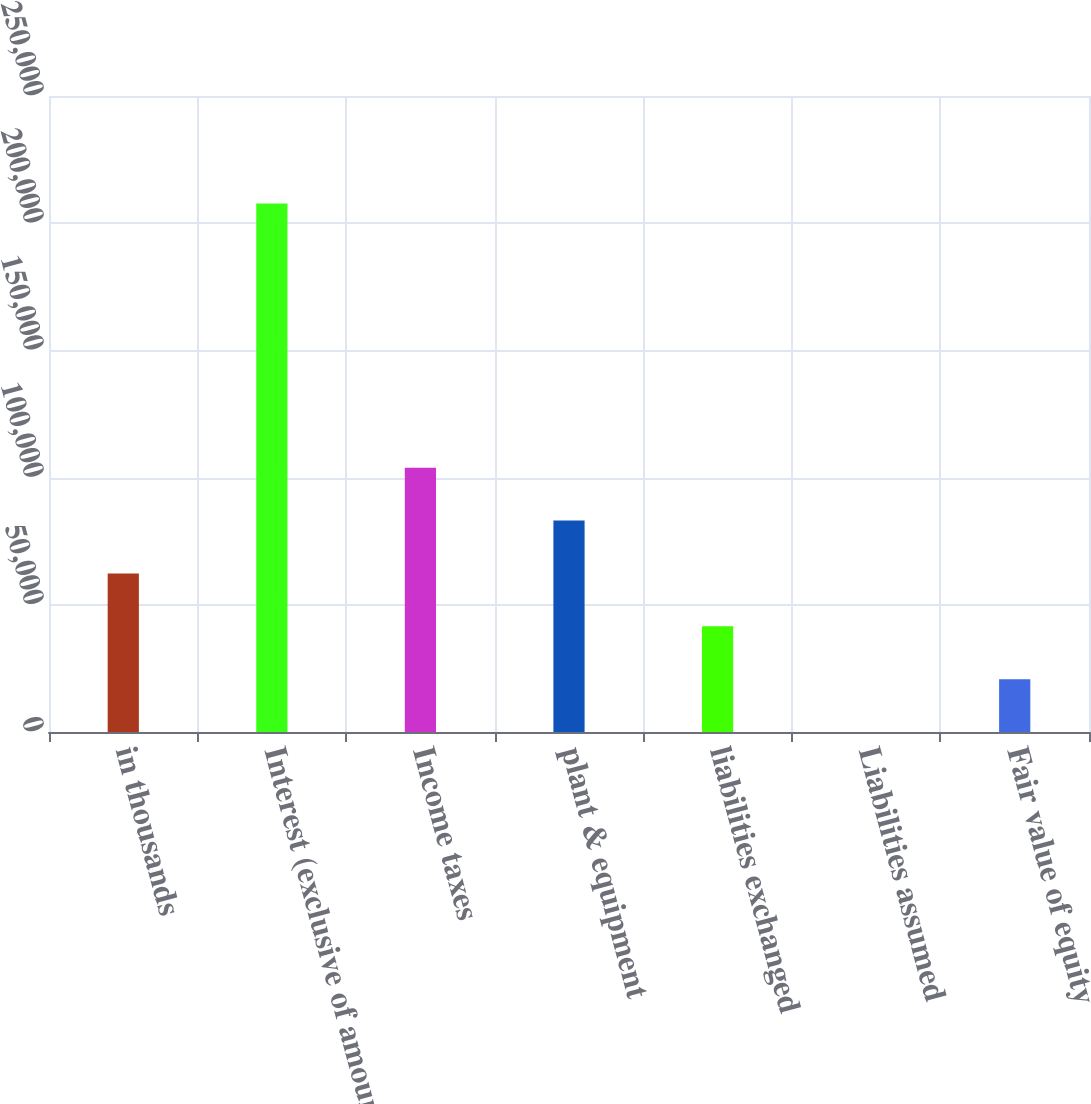<chart> <loc_0><loc_0><loc_500><loc_500><bar_chart><fcel>in thousands<fcel>Interest (exclusive of amount<fcel>Income taxes<fcel>plant & equipment<fcel>liabilities exchanged<fcel>Liabilities assumed<fcel>Fair value of equity<nl><fcel>62324.2<fcel>207745<fcel>103873<fcel>83098.6<fcel>41549.8<fcel>1<fcel>20775.4<nl></chart> 